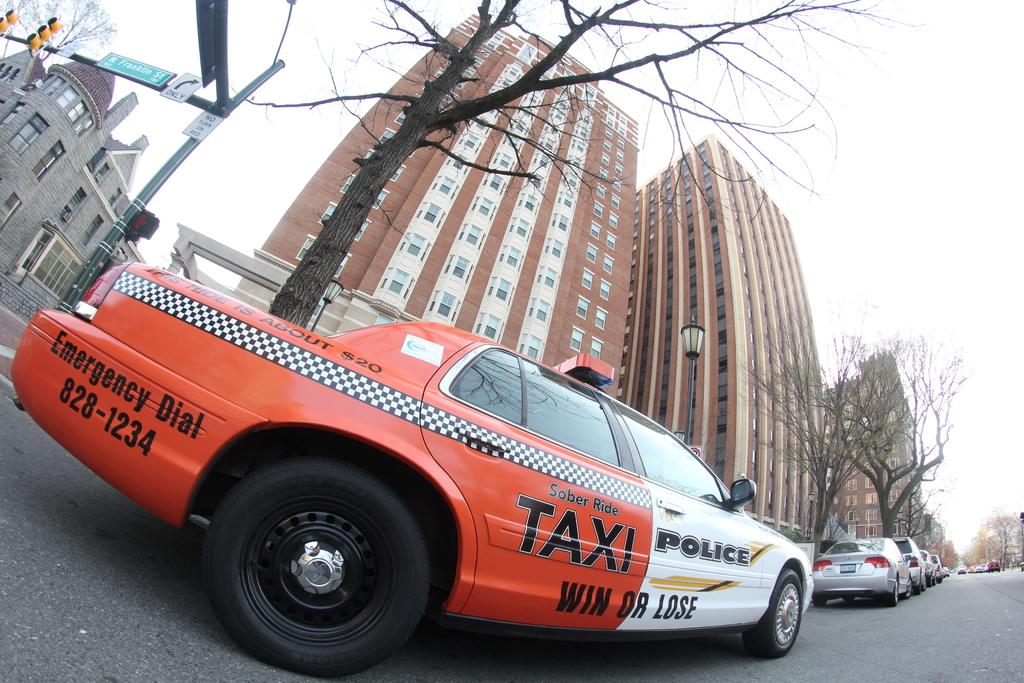Provide a one-sentence caption for the provided image. A red and white combination Taxi and Police vehicle on a street. 